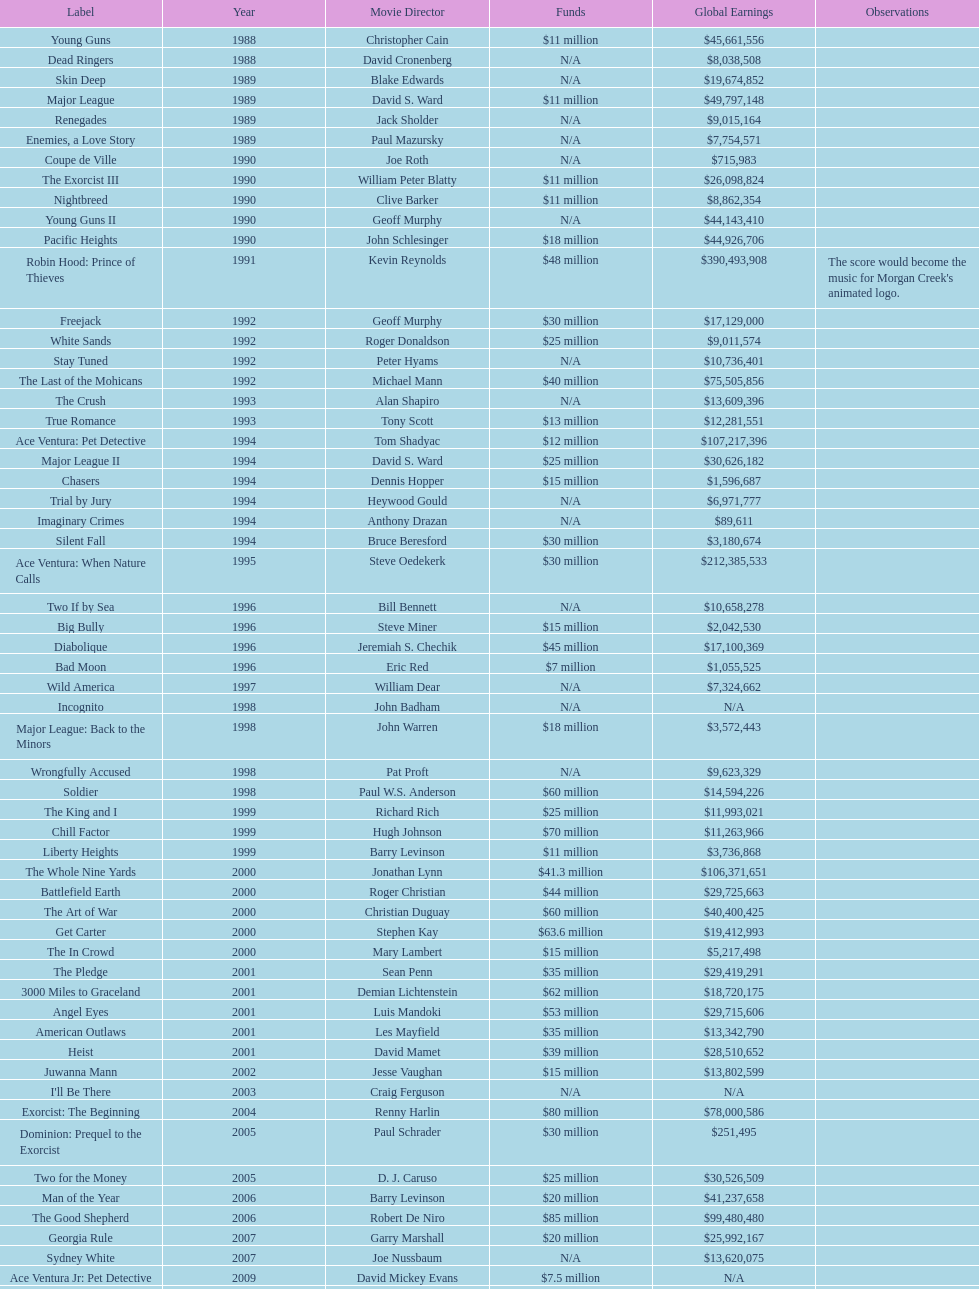How many films did morgan creek make in 2006? 2. Write the full table. {'header': ['Label', 'Year', 'Movie Director', 'Funds', 'Global Earnings', 'Observations'], 'rows': [['Young Guns', '1988', 'Christopher Cain', '$11 million', '$45,661,556', ''], ['Dead Ringers', '1988', 'David Cronenberg', 'N/A', '$8,038,508', ''], ['Skin Deep', '1989', 'Blake Edwards', 'N/A', '$19,674,852', ''], ['Major League', '1989', 'David S. Ward', '$11 million', '$49,797,148', ''], ['Renegades', '1989', 'Jack Sholder', 'N/A', '$9,015,164', ''], ['Enemies, a Love Story', '1989', 'Paul Mazursky', 'N/A', '$7,754,571', ''], ['Coupe de Ville', '1990', 'Joe Roth', 'N/A', '$715,983', ''], ['The Exorcist III', '1990', 'William Peter Blatty', '$11 million', '$26,098,824', ''], ['Nightbreed', '1990', 'Clive Barker', '$11 million', '$8,862,354', ''], ['Young Guns II', '1990', 'Geoff Murphy', 'N/A', '$44,143,410', ''], ['Pacific Heights', '1990', 'John Schlesinger', '$18 million', '$44,926,706', ''], ['Robin Hood: Prince of Thieves', '1991', 'Kevin Reynolds', '$48 million', '$390,493,908', "The score would become the music for Morgan Creek's animated logo."], ['Freejack', '1992', 'Geoff Murphy', '$30 million', '$17,129,000', ''], ['White Sands', '1992', 'Roger Donaldson', '$25 million', '$9,011,574', ''], ['Stay Tuned', '1992', 'Peter Hyams', 'N/A', '$10,736,401', ''], ['The Last of the Mohicans', '1992', 'Michael Mann', '$40 million', '$75,505,856', ''], ['The Crush', '1993', 'Alan Shapiro', 'N/A', '$13,609,396', ''], ['True Romance', '1993', 'Tony Scott', '$13 million', '$12,281,551', ''], ['Ace Ventura: Pet Detective', '1994', 'Tom Shadyac', '$12 million', '$107,217,396', ''], ['Major League II', '1994', 'David S. Ward', '$25 million', '$30,626,182', ''], ['Chasers', '1994', 'Dennis Hopper', '$15 million', '$1,596,687', ''], ['Trial by Jury', '1994', 'Heywood Gould', 'N/A', '$6,971,777', ''], ['Imaginary Crimes', '1994', 'Anthony Drazan', 'N/A', '$89,611', ''], ['Silent Fall', '1994', 'Bruce Beresford', '$30 million', '$3,180,674', ''], ['Ace Ventura: When Nature Calls', '1995', 'Steve Oedekerk', '$30 million', '$212,385,533', ''], ['Two If by Sea', '1996', 'Bill Bennett', 'N/A', '$10,658,278', ''], ['Big Bully', '1996', 'Steve Miner', '$15 million', '$2,042,530', ''], ['Diabolique', '1996', 'Jeremiah S. Chechik', '$45 million', '$17,100,369', ''], ['Bad Moon', '1996', 'Eric Red', '$7 million', '$1,055,525', ''], ['Wild America', '1997', 'William Dear', 'N/A', '$7,324,662', ''], ['Incognito', '1998', 'John Badham', 'N/A', 'N/A', ''], ['Major League: Back to the Minors', '1998', 'John Warren', '$18 million', '$3,572,443', ''], ['Wrongfully Accused', '1998', 'Pat Proft', 'N/A', '$9,623,329', ''], ['Soldier', '1998', 'Paul W.S. Anderson', '$60 million', '$14,594,226', ''], ['The King and I', '1999', 'Richard Rich', '$25 million', '$11,993,021', ''], ['Chill Factor', '1999', 'Hugh Johnson', '$70 million', '$11,263,966', ''], ['Liberty Heights', '1999', 'Barry Levinson', '$11 million', '$3,736,868', ''], ['The Whole Nine Yards', '2000', 'Jonathan Lynn', '$41.3 million', '$106,371,651', ''], ['Battlefield Earth', '2000', 'Roger Christian', '$44 million', '$29,725,663', ''], ['The Art of War', '2000', 'Christian Duguay', '$60 million', '$40,400,425', ''], ['Get Carter', '2000', 'Stephen Kay', '$63.6 million', '$19,412,993', ''], ['The In Crowd', '2000', 'Mary Lambert', '$15 million', '$5,217,498', ''], ['The Pledge', '2001', 'Sean Penn', '$35 million', '$29,419,291', ''], ['3000 Miles to Graceland', '2001', 'Demian Lichtenstein', '$62 million', '$18,720,175', ''], ['Angel Eyes', '2001', 'Luis Mandoki', '$53 million', '$29,715,606', ''], ['American Outlaws', '2001', 'Les Mayfield', '$35 million', '$13,342,790', ''], ['Heist', '2001', 'David Mamet', '$39 million', '$28,510,652', ''], ['Juwanna Mann', '2002', 'Jesse Vaughan', '$15 million', '$13,802,599', ''], ["I'll Be There", '2003', 'Craig Ferguson', 'N/A', 'N/A', ''], ['Exorcist: The Beginning', '2004', 'Renny Harlin', '$80 million', '$78,000,586', ''], ['Dominion: Prequel to the Exorcist', '2005', 'Paul Schrader', '$30 million', '$251,495', ''], ['Two for the Money', '2005', 'D. J. Caruso', '$25 million', '$30,526,509', ''], ['Man of the Year', '2006', 'Barry Levinson', '$20 million', '$41,237,658', ''], ['The Good Shepherd', '2006', 'Robert De Niro', '$85 million', '$99,480,480', ''], ['Georgia Rule', '2007', 'Garry Marshall', '$20 million', '$25,992,167', ''], ['Sydney White', '2007', 'Joe Nussbaum', 'N/A', '$13,620,075', ''], ['Ace Ventura Jr: Pet Detective', '2009', 'David Mickey Evans', '$7.5 million', 'N/A', ''], ['Dream House', '2011', 'Jim Sheridan', '$50 million', '$38,502,340', ''], ['The Thing', '2011', 'Matthijs van Heijningen Jr.', '$38 million', '$27,428,670', ''], ['Tupac', '2014', 'Antoine Fuqua', '$45 million', '', '']]} 